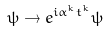Convert formula to latex. <formula><loc_0><loc_0><loc_500><loc_500>\psi \rightarrow e ^ { i \alpha ^ { k } t ^ { k } } \psi</formula> 